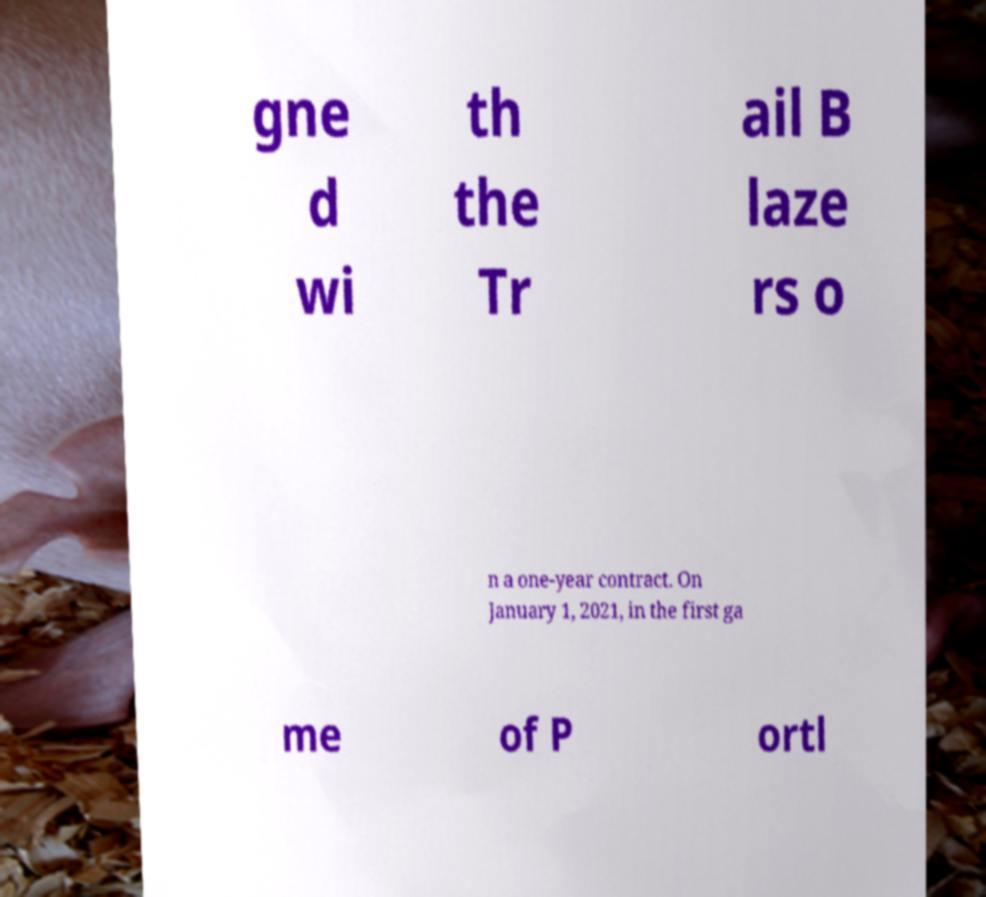Can you accurately transcribe the text from the provided image for me? gne d wi th the Tr ail B laze rs o n a one-year contract. On January 1, 2021, in the first ga me of P ortl 